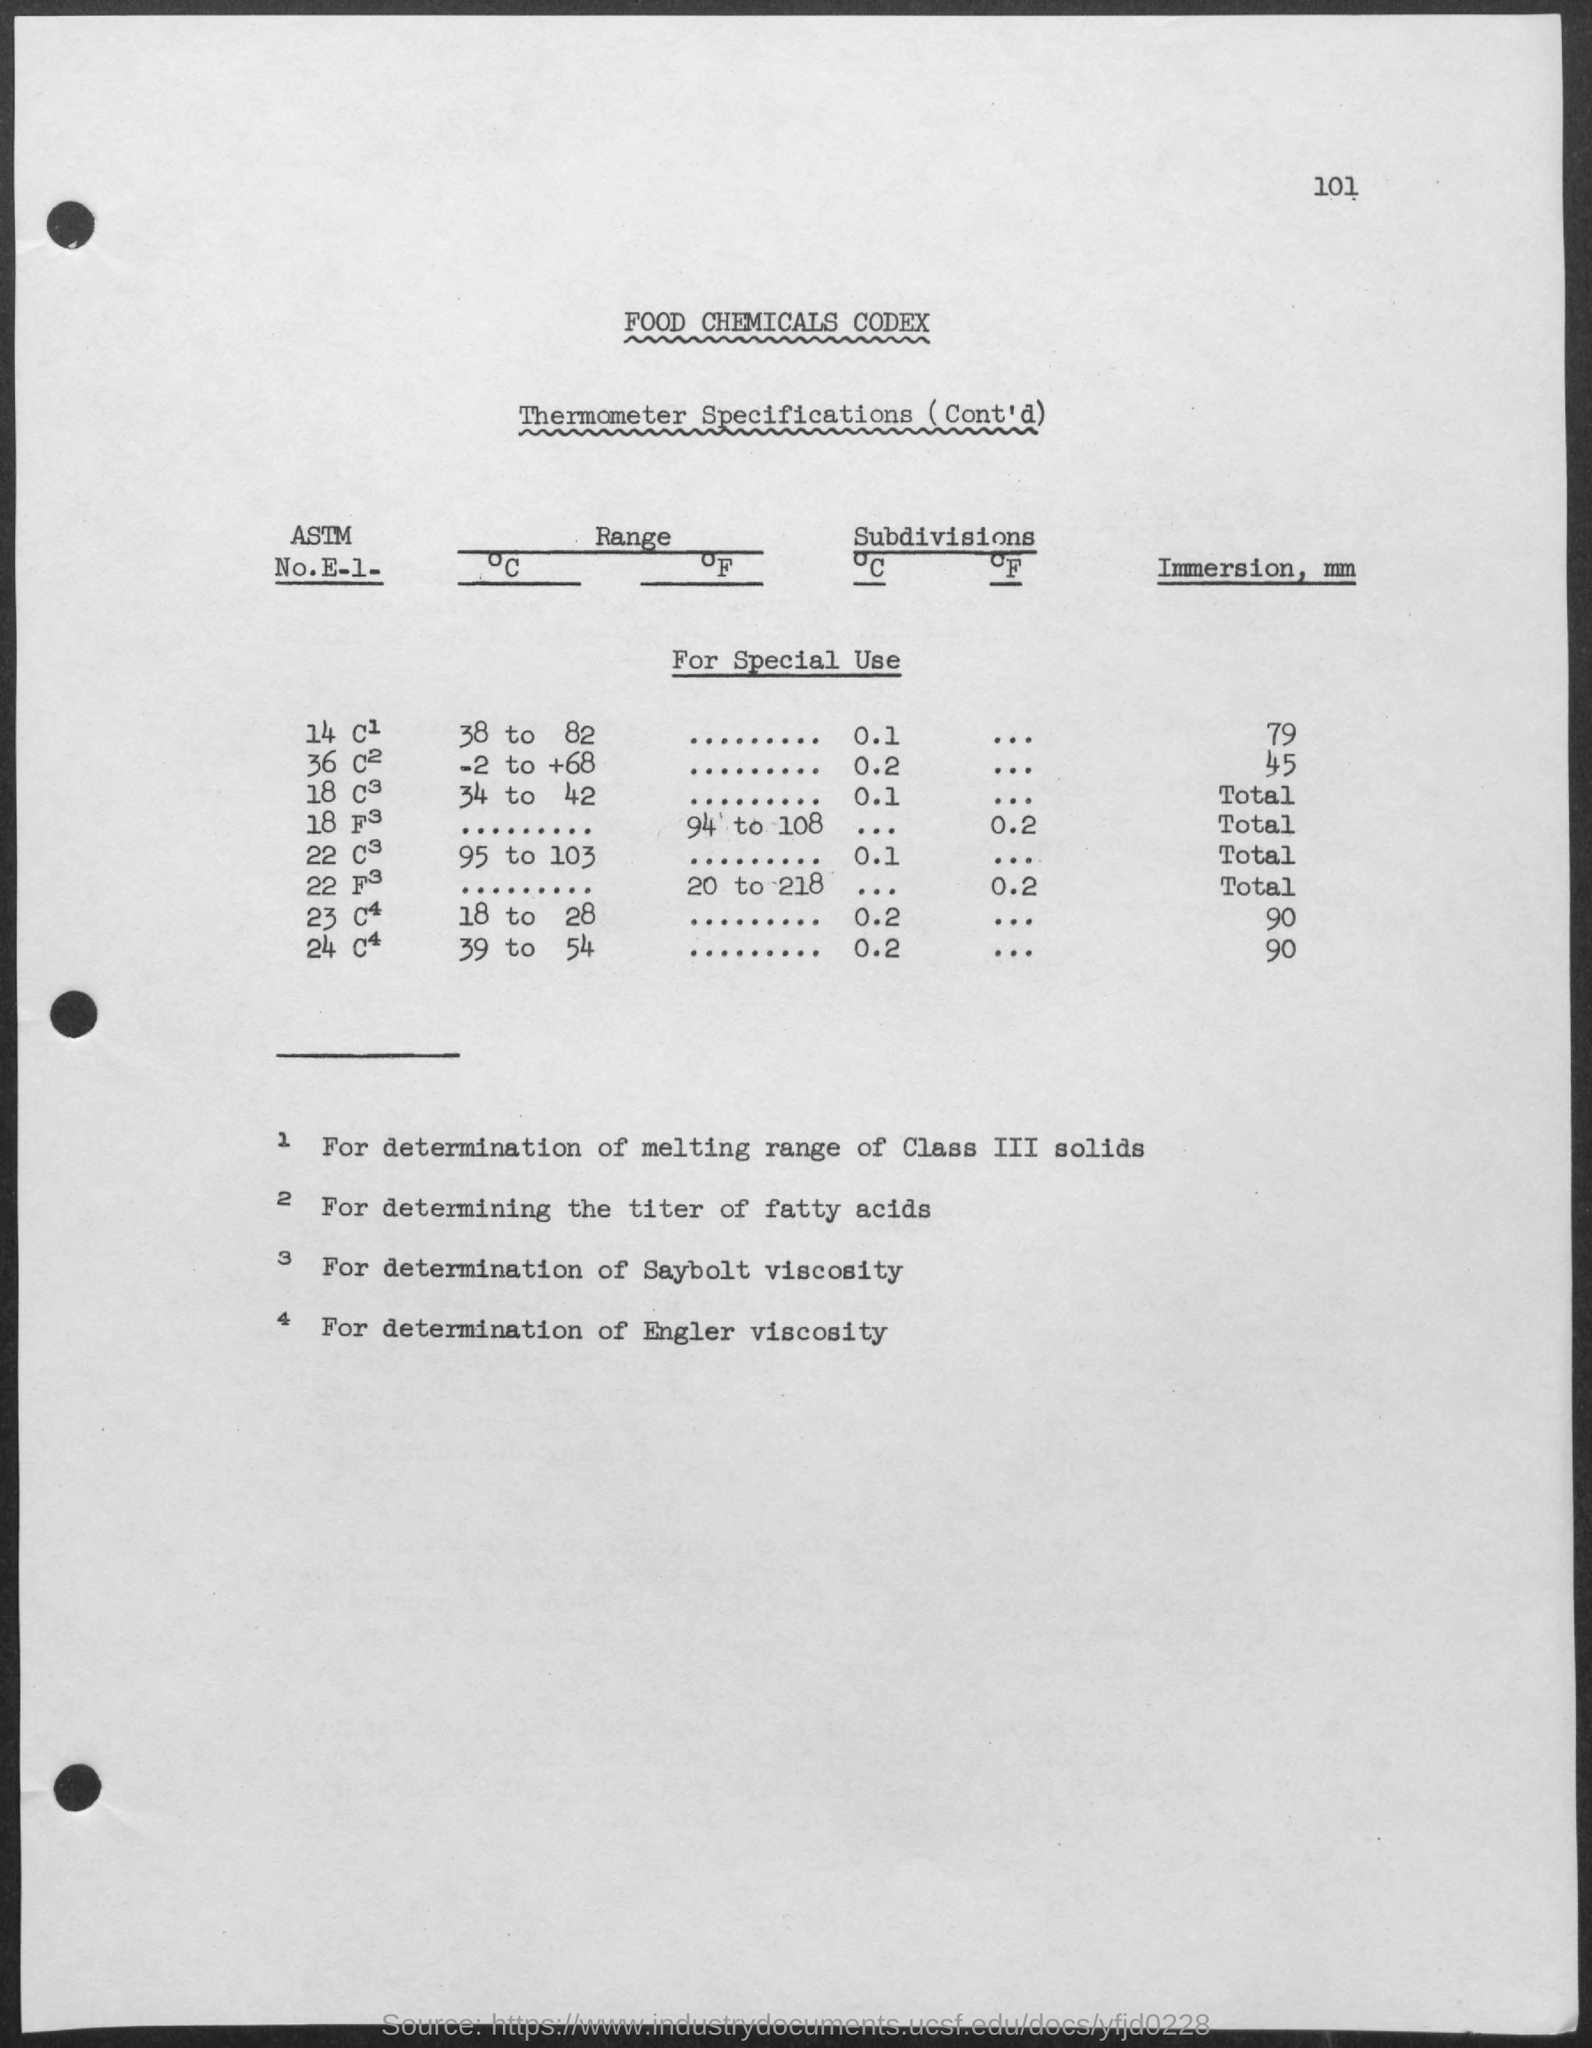Highlight a few significant elements in this photo. The second title in the document is 'Thermometer Specifications.' The page number is 101. The Food Chemicals Codex is the first title in the document. 